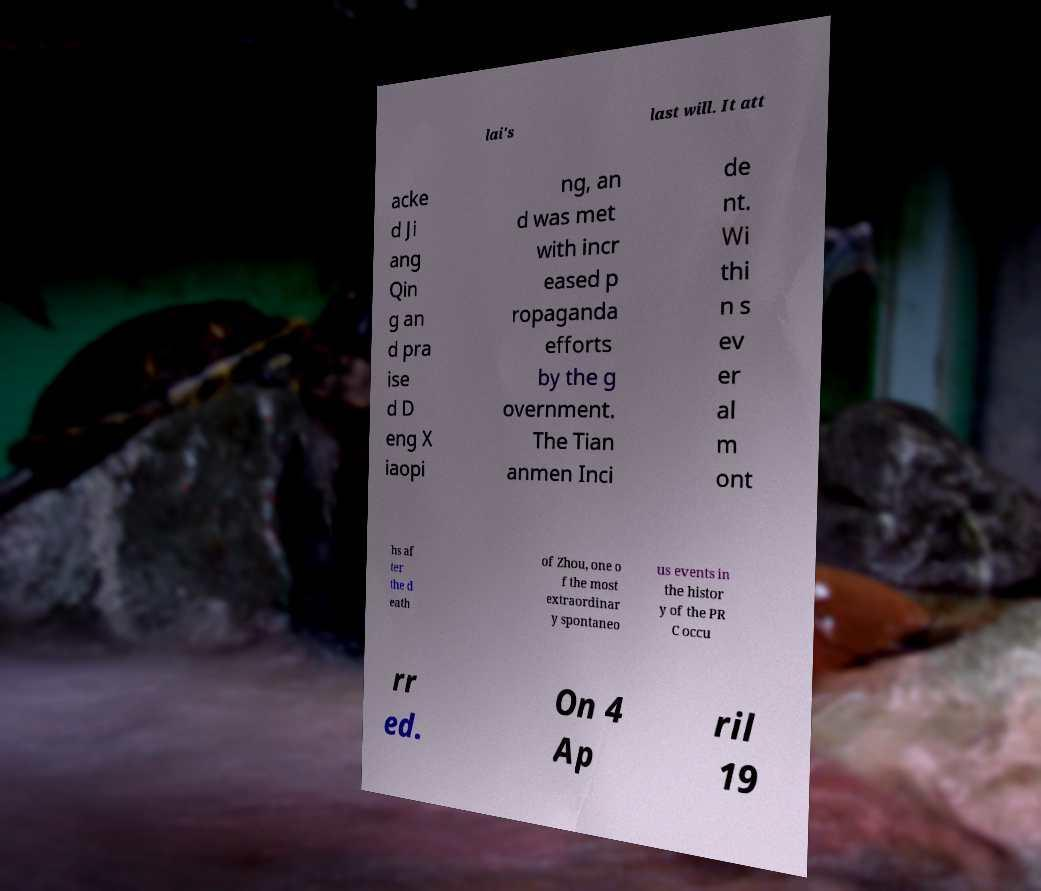Please identify and transcribe the text found in this image. lai's last will. It att acke d Ji ang Qin g an d pra ise d D eng X iaopi ng, an d was met with incr eased p ropaganda efforts by the g overnment. The Tian anmen Inci de nt. Wi thi n s ev er al m ont hs af ter the d eath of Zhou, one o f the most extraordinar y spontaneo us events in the histor y of the PR C occu rr ed. On 4 Ap ril 19 